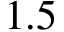Convert formula to latex. <formula><loc_0><loc_0><loc_500><loc_500>1 . 5</formula> 